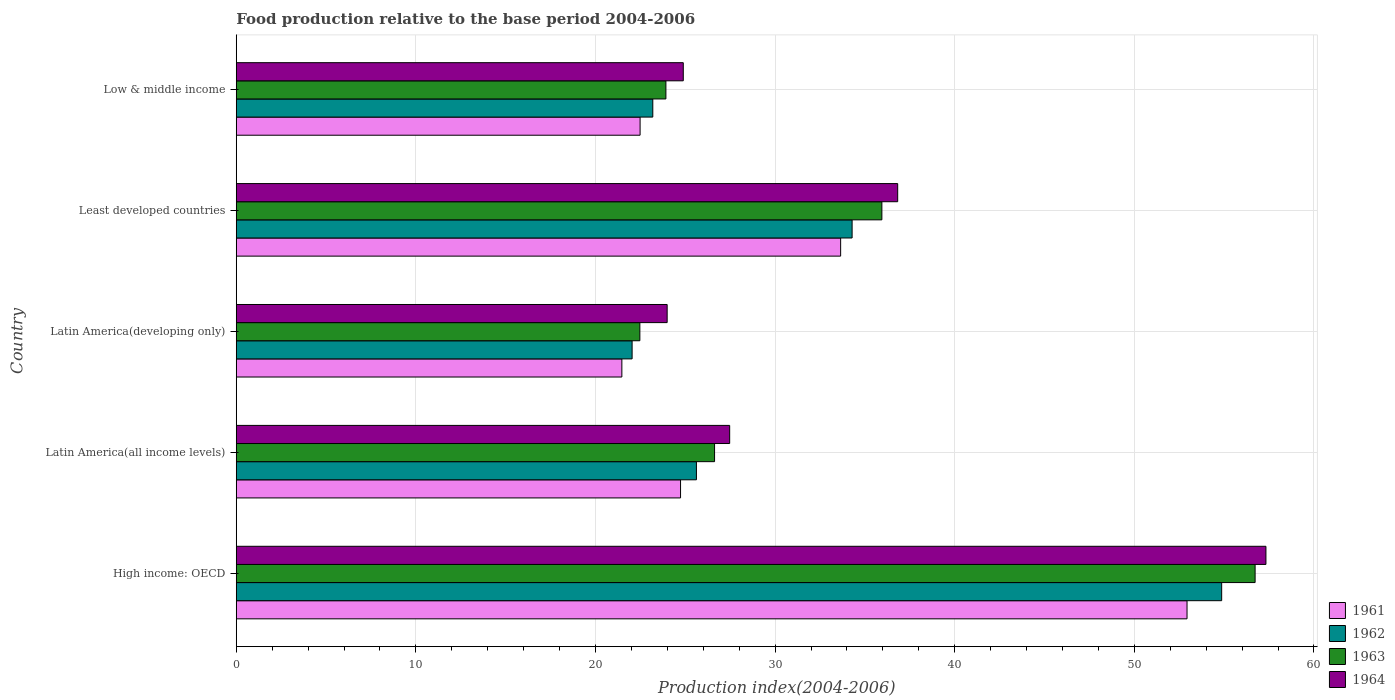Are the number of bars on each tick of the Y-axis equal?
Ensure brevity in your answer.  Yes. How many bars are there on the 2nd tick from the top?
Provide a succinct answer. 4. What is the label of the 3rd group of bars from the top?
Provide a succinct answer. Latin America(developing only). In how many cases, is the number of bars for a given country not equal to the number of legend labels?
Your response must be concise. 0. What is the food production index in 1963 in Low & middle income?
Keep it short and to the point. 23.92. Across all countries, what is the maximum food production index in 1961?
Give a very brief answer. 52.93. Across all countries, what is the minimum food production index in 1964?
Provide a succinct answer. 23.99. In which country was the food production index in 1963 maximum?
Make the answer very short. High income: OECD. In which country was the food production index in 1963 minimum?
Provide a succinct answer. Latin America(developing only). What is the total food production index in 1963 in the graph?
Your answer should be very brief. 165.69. What is the difference between the food production index in 1962 in High income: OECD and that in Low & middle income?
Ensure brevity in your answer.  31.67. What is the difference between the food production index in 1961 in Latin America(all income levels) and the food production index in 1964 in Low & middle income?
Your answer should be very brief. -0.15. What is the average food production index in 1963 per country?
Your answer should be very brief. 33.14. What is the difference between the food production index in 1961 and food production index in 1962 in Low & middle income?
Your response must be concise. -0.71. In how many countries, is the food production index in 1963 greater than 20 ?
Offer a very short reply. 5. What is the ratio of the food production index in 1964 in Latin America(developing only) to that in Least developed countries?
Your response must be concise. 0.65. Is the food production index in 1961 in Latin America(developing only) less than that in Least developed countries?
Ensure brevity in your answer.  Yes. Is the difference between the food production index in 1961 in Latin America(all income levels) and Latin America(developing only) greater than the difference between the food production index in 1962 in Latin America(all income levels) and Latin America(developing only)?
Provide a succinct answer. No. What is the difference between the highest and the second highest food production index in 1961?
Keep it short and to the point. 19.29. What is the difference between the highest and the lowest food production index in 1963?
Offer a terse response. 34.25. What does the 2nd bar from the bottom in Low & middle income represents?
Your answer should be compact. 1962. Is it the case that in every country, the sum of the food production index in 1963 and food production index in 1964 is greater than the food production index in 1961?
Provide a short and direct response. Yes. Are all the bars in the graph horizontal?
Provide a short and direct response. Yes. What is the difference between two consecutive major ticks on the X-axis?
Make the answer very short. 10. Are the values on the major ticks of X-axis written in scientific E-notation?
Your response must be concise. No. Does the graph contain grids?
Your answer should be very brief. Yes. Where does the legend appear in the graph?
Ensure brevity in your answer.  Bottom right. How are the legend labels stacked?
Give a very brief answer. Vertical. What is the title of the graph?
Your answer should be compact. Food production relative to the base period 2004-2006. Does "2010" appear as one of the legend labels in the graph?
Make the answer very short. No. What is the label or title of the X-axis?
Your answer should be very brief. Production index(2004-2006). What is the label or title of the Y-axis?
Offer a terse response. Country. What is the Production index(2004-2006) in 1961 in High income: OECD?
Your response must be concise. 52.93. What is the Production index(2004-2006) in 1962 in High income: OECD?
Provide a succinct answer. 54.86. What is the Production index(2004-2006) of 1963 in High income: OECD?
Provide a short and direct response. 56.73. What is the Production index(2004-2006) in 1964 in High income: OECD?
Your answer should be very brief. 57.33. What is the Production index(2004-2006) of 1961 in Latin America(all income levels)?
Your response must be concise. 24.74. What is the Production index(2004-2006) of 1962 in Latin America(all income levels)?
Ensure brevity in your answer.  25.62. What is the Production index(2004-2006) of 1963 in Latin America(all income levels)?
Your answer should be compact. 26.63. What is the Production index(2004-2006) of 1964 in Latin America(all income levels)?
Give a very brief answer. 27.47. What is the Production index(2004-2006) in 1961 in Latin America(developing only)?
Ensure brevity in your answer.  21.47. What is the Production index(2004-2006) in 1962 in Latin America(developing only)?
Provide a succinct answer. 22.04. What is the Production index(2004-2006) in 1963 in Latin America(developing only)?
Provide a succinct answer. 22.47. What is the Production index(2004-2006) of 1964 in Latin America(developing only)?
Your response must be concise. 23.99. What is the Production index(2004-2006) in 1961 in Least developed countries?
Provide a succinct answer. 33.65. What is the Production index(2004-2006) in 1962 in Least developed countries?
Ensure brevity in your answer.  34.29. What is the Production index(2004-2006) of 1963 in Least developed countries?
Offer a very short reply. 35.95. What is the Production index(2004-2006) of 1964 in Least developed countries?
Your response must be concise. 36.83. What is the Production index(2004-2006) in 1961 in Low & middle income?
Give a very brief answer. 22.48. What is the Production index(2004-2006) of 1962 in Low & middle income?
Provide a succinct answer. 23.19. What is the Production index(2004-2006) in 1963 in Low & middle income?
Provide a short and direct response. 23.92. What is the Production index(2004-2006) of 1964 in Low & middle income?
Provide a succinct answer. 24.89. Across all countries, what is the maximum Production index(2004-2006) of 1961?
Make the answer very short. 52.93. Across all countries, what is the maximum Production index(2004-2006) in 1962?
Your answer should be very brief. 54.86. Across all countries, what is the maximum Production index(2004-2006) in 1963?
Provide a succinct answer. 56.73. Across all countries, what is the maximum Production index(2004-2006) in 1964?
Your response must be concise. 57.33. Across all countries, what is the minimum Production index(2004-2006) of 1961?
Your response must be concise. 21.47. Across all countries, what is the minimum Production index(2004-2006) in 1962?
Ensure brevity in your answer.  22.04. Across all countries, what is the minimum Production index(2004-2006) in 1963?
Your answer should be very brief. 22.47. Across all countries, what is the minimum Production index(2004-2006) of 1964?
Keep it short and to the point. 23.99. What is the total Production index(2004-2006) in 1961 in the graph?
Give a very brief answer. 155.27. What is the total Production index(2004-2006) in 1962 in the graph?
Your answer should be very brief. 160. What is the total Production index(2004-2006) of 1963 in the graph?
Offer a very short reply. 165.69. What is the total Production index(2004-2006) of 1964 in the graph?
Offer a terse response. 170.5. What is the difference between the Production index(2004-2006) in 1961 in High income: OECD and that in Latin America(all income levels)?
Keep it short and to the point. 28.2. What is the difference between the Production index(2004-2006) in 1962 in High income: OECD and that in Latin America(all income levels)?
Make the answer very short. 29.24. What is the difference between the Production index(2004-2006) in 1963 in High income: OECD and that in Latin America(all income levels)?
Your response must be concise. 30.1. What is the difference between the Production index(2004-2006) of 1964 in High income: OECD and that in Latin America(all income levels)?
Give a very brief answer. 29.86. What is the difference between the Production index(2004-2006) in 1961 in High income: OECD and that in Latin America(developing only)?
Make the answer very short. 31.47. What is the difference between the Production index(2004-2006) of 1962 in High income: OECD and that in Latin America(developing only)?
Provide a short and direct response. 32.82. What is the difference between the Production index(2004-2006) of 1963 in High income: OECD and that in Latin America(developing only)?
Give a very brief answer. 34.25. What is the difference between the Production index(2004-2006) of 1964 in High income: OECD and that in Latin America(developing only)?
Offer a terse response. 33.34. What is the difference between the Production index(2004-2006) of 1961 in High income: OECD and that in Least developed countries?
Offer a terse response. 19.29. What is the difference between the Production index(2004-2006) of 1962 in High income: OECD and that in Least developed countries?
Keep it short and to the point. 20.57. What is the difference between the Production index(2004-2006) in 1963 in High income: OECD and that in Least developed countries?
Your response must be concise. 20.78. What is the difference between the Production index(2004-2006) of 1964 in High income: OECD and that in Least developed countries?
Give a very brief answer. 20.5. What is the difference between the Production index(2004-2006) of 1961 in High income: OECD and that in Low & middle income?
Keep it short and to the point. 30.45. What is the difference between the Production index(2004-2006) in 1962 in High income: OECD and that in Low & middle income?
Provide a succinct answer. 31.67. What is the difference between the Production index(2004-2006) of 1963 in High income: OECD and that in Low & middle income?
Offer a very short reply. 32.8. What is the difference between the Production index(2004-2006) of 1964 in High income: OECD and that in Low & middle income?
Offer a very short reply. 32.44. What is the difference between the Production index(2004-2006) of 1961 in Latin America(all income levels) and that in Latin America(developing only)?
Your response must be concise. 3.27. What is the difference between the Production index(2004-2006) in 1962 in Latin America(all income levels) and that in Latin America(developing only)?
Ensure brevity in your answer.  3.58. What is the difference between the Production index(2004-2006) of 1963 in Latin America(all income levels) and that in Latin America(developing only)?
Provide a succinct answer. 4.16. What is the difference between the Production index(2004-2006) of 1964 in Latin America(all income levels) and that in Latin America(developing only)?
Provide a short and direct response. 3.48. What is the difference between the Production index(2004-2006) in 1961 in Latin America(all income levels) and that in Least developed countries?
Keep it short and to the point. -8.91. What is the difference between the Production index(2004-2006) of 1962 in Latin America(all income levels) and that in Least developed countries?
Provide a succinct answer. -8.67. What is the difference between the Production index(2004-2006) of 1963 in Latin America(all income levels) and that in Least developed countries?
Your response must be concise. -9.32. What is the difference between the Production index(2004-2006) of 1964 in Latin America(all income levels) and that in Least developed countries?
Make the answer very short. -9.35. What is the difference between the Production index(2004-2006) in 1961 in Latin America(all income levels) and that in Low & middle income?
Provide a short and direct response. 2.25. What is the difference between the Production index(2004-2006) in 1962 in Latin America(all income levels) and that in Low & middle income?
Your answer should be compact. 2.43. What is the difference between the Production index(2004-2006) in 1963 in Latin America(all income levels) and that in Low & middle income?
Keep it short and to the point. 2.71. What is the difference between the Production index(2004-2006) in 1964 in Latin America(all income levels) and that in Low & middle income?
Your answer should be very brief. 2.58. What is the difference between the Production index(2004-2006) in 1961 in Latin America(developing only) and that in Least developed countries?
Offer a very short reply. -12.18. What is the difference between the Production index(2004-2006) in 1962 in Latin America(developing only) and that in Least developed countries?
Keep it short and to the point. -12.25. What is the difference between the Production index(2004-2006) of 1963 in Latin America(developing only) and that in Least developed countries?
Ensure brevity in your answer.  -13.47. What is the difference between the Production index(2004-2006) in 1964 in Latin America(developing only) and that in Least developed countries?
Provide a short and direct response. -12.83. What is the difference between the Production index(2004-2006) of 1961 in Latin America(developing only) and that in Low & middle income?
Offer a very short reply. -1.01. What is the difference between the Production index(2004-2006) of 1962 in Latin America(developing only) and that in Low & middle income?
Offer a very short reply. -1.15. What is the difference between the Production index(2004-2006) in 1963 in Latin America(developing only) and that in Low & middle income?
Offer a very short reply. -1.45. What is the difference between the Production index(2004-2006) in 1964 in Latin America(developing only) and that in Low & middle income?
Ensure brevity in your answer.  -0.9. What is the difference between the Production index(2004-2006) in 1961 in Least developed countries and that in Low & middle income?
Offer a very short reply. 11.17. What is the difference between the Production index(2004-2006) in 1962 in Least developed countries and that in Low & middle income?
Make the answer very short. 11.1. What is the difference between the Production index(2004-2006) in 1963 in Least developed countries and that in Low & middle income?
Make the answer very short. 12.02. What is the difference between the Production index(2004-2006) of 1964 in Least developed countries and that in Low & middle income?
Your response must be concise. 11.94. What is the difference between the Production index(2004-2006) of 1961 in High income: OECD and the Production index(2004-2006) of 1962 in Latin America(all income levels)?
Make the answer very short. 27.31. What is the difference between the Production index(2004-2006) of 1961 in High income: OECD and the Production index(2004-2006) of 1963 in Latin America(all income levels)?
Offer a very short reply. 26.3. What is the difference between the Production index(2004-2006) in 1961 in High income: OECD and the Production index(2004-2006) in 1964 in Latin America(all income levels)?
Make the answer very short. 25.46. What is the difference between the Production index(2004-2006) in 1962 in High income: OECD and the Production index(2004-2006) in 1963 in Latin America(all income levels)?
Offer a very short reply. 28.23. What is the difference between the Production index(2004-2006) in 1962 in High income: OECD and the Production index(2004-2006) in 1964 in Latin America(all income levels)?
Ensure brevity in your answer.  27.39. What is the difference between the Production index(2004-2006) in 1963 in High income: OECD and the Production index(2004-2006) in 1964 in Latin America(all income levels)?
Give a very brief answer. 29.25. What is the difference between the Production index(2004-2006) of 1961 in High income: OECD and the Production index(2004-2006) of 1962 in Latin America(developing only)?
Provide a short and direct response. 30.89. What is the difference between the Production index(2004-2006) in 1961 in High income: OECD and the Production index(2004-2006) in 1963 in Latin America(developing only)?
Provide a succinct answer. 30.46. What is the difference between the Production index(2004-2006) in 1961 in High income: OECD and the Production index(2004-2006) in 1964 in Latin America(developing only)?
Your answer should be compact. 28.94. What is the difference between the Production index(2004-2006) of 1962 in High income: OECD and the Production index(2004-2006) of 1963 in Latin America(developing only)?
Your answer should be compact. 32.39. What is the difference between the Production index(2004-2006) in 1962 in High income: OECD and the Production index(2004-2006) in 1964 in Latin America(developing only)?
Provide a succinct answer. 30.87. What is the difference between the Production index(2004-2006) of 1963 in High income: OECD and the Production index(2004-2006) of 1964 in Latin America(developing only)?
Your answer should be compact. 32.73. What is the difference between the Production index(2004-2006) in 1961 in High income: OECD and the Production index(2004-2006) in 1962 in Least developed countries?
Your response must be concise. 18.65. What is the difference between the Production index(2004-2006) of 1961 in High income: OECD and the Production index(2004-2006) of 1963 in Least developed countries?
Ensure brevity in your answer.  16.99. What is the difference between the Production index(2004-2006) in 1961 in High income: OECD and the Production index(2004-2006) in 1964 in Least developed countries?
Provide a short and direct response. 16.11. What is the difference between the Production index(2004-2006) of 1962 in High income: OECD and the Production index(2004-2006) of 1963 in Least developed countries?
Offer a terse response. 18.92. What is the difference between the Production index(2004-2006) of 1962 in High income: OECD and the Production index(2004-2006) of 1964 in Least developed countries?
Your answer should be compact. 18.04. What is the difference between the Production index(2004-2006) in 1961 in High income: OECD and the Production index(2004-2006) in 1962 in Low & middle income?
Offer a very short reply. 29.74. What is the difference between the Production index(2004-2006) of 1961 in High income: OECD and the Production index(2004-2006) of 1963 in Low & middle income?
Ensure brevity in your answer.  29.01. What is the difference between the Production index(2004-2006) of 1961 in High income: OECD and the Production index(2004-2006) of 1964 in Low & middle income?
Your answer should be compact. 28.05. What is the difference between the Production index(2004-2006) in 1962 in High income: OECD and the Production index(2004-2006) in 1963 in Low & middle income?
Offer a very short reply. 30.94. What is the difference between the Production index(2004-2006) of 1962 in High income: OECD and the Production index(2004-2006) of 1964 in Low & middle income?
Your response must be concise. 29.97. What is the difference between the Production index(2004-2006) in 1963 in High income: OECD and the Production index(2004-2006) in 1964 in Low & middle income?
Your answer should be very brief. 31.84. What is the difference between the Production index(2004-2006) of 1961 in Latin America(all income levels) and the Production index(2004-2006) of 1962 in Latin America(developing only)?
Offer a very short reply. 2.7. What is the difference between the Production index(2004-2006) of 1961 in Latin America(all income levels) and the Production index(2004-2006) of 1963 in Latin America(developing only)?
Your response must be concise. 2.27. What is the difference between the Production index(2004-2006) in 1961 in Latin America(all income levels) and the Production index(2004-2006) in 1964 in Latin America(developing only)?
Offer a very short reply. 0.75. What is the difference between the Production index(2004-2006) of 1962 in Latin America(all income levels) and the Production index(2004-2006) of 1963 in Latin America(developing only)?
Ensure brevity in your answer.  3.15. What is the difference between the Production index(2004-2006) in 1962 in Latin America(all income levels) and the Production index(2004-2006) in 1964 in Latin America(developing only)?
Ensure brevity in your answer.  1.63. What is the difference between the Production index(2004-2006) in 1963 in Latin America(all income levels) and the Production index(2004-2006) in 1964 in Latin America(developing only)?
Offer a terse response. 2.64. What is the difference between the Production index(2004-2006) of 1961 in Latin America(all income levels) and the Production index(2004-2006) of 1962 in Least developed countries?
Offer a terse response. -9.55. What is the difference between the Production index(2004-2006) in 1961 in Latin America(all income levels) and the Production index(2004-2006) in 1963 in Least developed countries?
Your answer should be very brief. -11.21. What is the difference between the Production index(2004-2006) of 1961 in Latin America(all income levels) and the Production index(2004-2006) of 1964 in Least developed countries?
Your answer should be compact. -12.09. What is the difference between the Production index(2004-2006) in 1962 in Latin America(all income levels) and the Production index(2004-2006) in 1963 in Least developed countries?
Give a very brief answer. -10.33. What is the difference between the Production index(2004-2006) in 1962 in Latin America(all income levels) and the Production index(2004-2006) in 1964 in Least developed countries?
Make the answer very short. -11.21. What is the difference between the Production index(2004-2006) in 1963 in Latin America(all income levels) and the Production index(2004-2006) in 1964 in Least developed countries?
Ensure brevity in your answer.  -10.2. What is the difference between the Production index(2004-2006) in 1961 in Latin America(all income levels) and the Production index(2004-2006) in 1962 in Low & middle income?
Offer a terse response. 1.54. What is the difference between the Production index(2004-2006) of 1961 in Latin America(all income levels) and the Production index(2004-2006) of 1963 in Low & middle income?
Give a very brief answer. 0.82. What is the difference between the Production index(2004-2006) in 1961 in Latin America(all income levels) and the Production index(2004-2006) in 1964 in Low & middle income?
Provide a succinct answer. -0.15. What is the difference between the Production index(2004-2006) in 1962 in Latin America(all income levels) and the Production index(2004-2006) in 1963 in Low & middle income?
Your answer should be very brief. 1.7. What is the difference between the Production index(2004-2006) of 1962 in Latin America(all income levels) and the Production index(2004-2006) of 1964 in Low & middle income?
Provide a short and direct response. 0.73. What is the difference between the Production index(2004-2006) in 1963 in Latin America(all income levels) and the Production index(2004-2006) in 1964 in Low & middle income?
Your answer should be compact. 1.74. What is the difference between the Production index(2004-2006) in 1961 in Latin America(developing only) and the Production index(2004-2006) in 1962 in Least developed countries?
Your answer should be compact. -12.82. What is the difference between the Production index(2004-2006) of 1961 in Latin America(developing only) and the Production index(2004-2006) of 1963 in Least developed countries?
Provide a succinct answer. -14.48. What is the difference between the Production index(2004-2006) in 1961 in Latin America(developing only) and the Production index(2004-2006) in 1964 in Least developed countries?
Ensure brevity in your answer.  -15.36. What is the difference between the Production index(2004-2006) of 1962 in Latin America(developing only) and the Production index(2004-2006) of 1963 in Least developed countries?
Your response must be concise. -13.91. What is the difference between the Production index(2004-2006) in 1962 in Latin America(developing only) and the Production index(2004-2006) in 1964 in Least developed countries?
Offer a terse response. -14.79. What is the difference between the Production index(2004-2006) in 1963 in Latin America(developing only) and the Production index(2004-2006) in 1964 in Least developed countries?
Your answer should be very brief. -14.35. What is the difference between the Production index(2004-2006) of 1961 in Latin America(developing only) and the Production index(2004-2006) of 1962 in Low & middle income?
Offer a very short reply. -1.72. What is the difference between the Production index(2004-2006) in 1961 in Latin America(developing only) and the Production index(2004-2006) in 1963 in Low & middle income?
Keep it short and to the point. -2.45. What is the difference between the Production index(2004-2006) of 1961 in Latin America(developing only) and the Production index(2004-2006) of 1964 in Low & middle income?
Keep it short and to the point. -3.42. What is the difference between the Production index(2004-2006) in 1962 in Latin America(developing only) and the Production index(2004-2006) in 1963 in Low & middle income?
Provide a succinct answer. -1.88. What is the difference between the Production index(2004-2006) of 1962 in Latin America(developing only) and the Production index(2004-2006) of 1964 in Low & middle income?
Your response must be concise. -2.85. What is the difference between the Production index(2004-2006) in 1963 in Latin America(developing only) and the Production index(2004-2006) in 1964 in Low & middle income?
Your answer should be very brief. -2.42. What is the difference between the Production index(2004-2006) in 1961 in Least developed countries and the Production index(2004-2006) in 1962 in Low & middle income?
Give a very brief answer. 10.46. What is the difference between the Production index(2004-2006) of 1961 in Least developed countries and the Production index(2004-2006) of 1963 in Low & middle income?
Make the answer very short. 9.73. What is the difference between the Production index(2004-2006) of 1961 in Least developed countries and the Production index(2004-2006) of 1964 in Low & middle income?
Provide a short and direct response. 8.76. What is the difference between the Production index(2004-2006) of 1962 in Least developed countries and the Production index(2004-2006) of 1963 in Low & middle income?
Ensure brevity in your answer.  10.37. What is the difference between the Production index(2004-2006) of 1962 in Least developed countries and the Production index(2004-2006) of 1964 in Low & middle income?
Provide a succinct answer. 9.4. What is the difference between the Production index(2004-2006) in 1963 in Least developed countries and the Production index(2004-2006) in 1964 in Low & middle income?
Make the answer very short. 11.06. What is the average Production index(2004-2006) in 1961 per country?
Make the answer very short. 31.05. What is the average Production index(2004-2006) in 1962 per country?
Offer a very short reply. 32. What is the average Production index(2004-2006) of 1963 per country?
Your answer should be very brief. 33.14. What is the average Production index(2004-2006) in 1964 per country?
Offer a terse response. 34.1. What is the difference between the Production index(2004-2006) in 1961 and Production index(2004-2006) in 1962 in High income: OECD?
Make the answer very short. -1.93. What is the difference between the Production index(2004-2006) in 1961 and Production index(2004-2006) in 1963 in High income: OECD?
Your answer should be very brief. -3.79. What is the difference between the Production index(2004-2006) in 1961 and Production index(2004-2006) in 1964 in High income: OECD?
Keep it short and to the point. -4.39. What is the difference between the Production index(2004-2006) in 1962 and Production index(2004-2006) in 1963 in High income: OECD?
Your answer should be compact. -1.86. What is the difference between the Production index(2004-2006) in 1962 and Production index(2004-2006) in 1964 in High income: OECD?
Ensure brevity in your answer.  -2.47. What is the difference between the Production index(2004-2006) of 1963 and Production index(2004-2006) of 1964 in High income: OECD?
Give a very brief answer. -0.6. What is the difference between the Production index(2004-2006) of 1961 and Production index(2004-2006) of 1962 in Latin America(all income levels)?
Provide a short and direct response. -0.88. What is the difference between the Production index(2004-2006) in 1961 and Production index(2004-2006) in 1963 in Latin America(all income levels)?
Offer a very short reply. -1.89. What is the difference between the Production index(2004-2006) of 1961 and Production index(2004-2006) of 1964 in Latin America(all income levels)?
Provide a succinct answer. -2.74. What is the difference between the Production index(2004-2006) in 1962 and Production index(2004-2006) in 1963 in Latin America(all income levels)?
Provide a short and direct response. -1.01. What is the difference between the Production index(2004-2006) in 1962 and Production index(2004-2006) in 1964 in Latin America(all income levels)?
Provide a succinct answer. -1.85. What is the difference between the Production index(2004-2006) of 1963 and Production index(2004-2006) of 1964 in Latin America(all income levels)?
Give a very brief answer. -0.84. What is the difference between the Production index(2004-2006) of 1961 and Production index(2004-2006) of 1962 in Latin America(developing only)?
Offer a very short reply. -0.57. What is the difference between the Production index(2004-2006) in 1961 and Production index(2004-2006) in 1963 in Latin America(developing only)?
Make the answer very short. -1. What is the difference between the Production index(2004-2006) of 1961 and Production index(2004-2006) of 1964 in Latin America(developing only)?
Ensure brevity in your answer.  -2.52. What is the difference between the Production index(2004-2006) of 1962 and Production index(2004-2006) of 1963 in Latin America(developing only)?
Your response must be concise. -0.43. What is the difference between the Production index(2004-2006) in 1962 and Production index(2004-2006) in 1964 in Latin America(developing only)?
Your answer should be compact. -1.95. What is the difference between the Production index(2004-2006) of 1963 and Production index(2004-2006) of 1964 in Latin America(developing only)?
Make the answer very short. -1.52. What is the difference between the Production index(2004-2006) of 1961 and Production index(2004-2006) of 1962 in Least developed countries?
Provide a succinct answer. -0.64. What is the difference between the Production index(2004-2006) in 1961 and Production index(2004-2006) in 1963 in Least developed countries?
Provide a short and direct response. -2.3. What is the difference between the Production index(2004-2006) of 1961 and Production index(2004-2006) of 1964 in Least developed countries?
Ensure brevity in your answer.  -3.18. What is the difference between the Production index(2004-2006) in 1962 and Production index(2004-2006) in 1963 in Least developed countries?
Keep it short and to the point. -1.66. What is the difference between the Production index(2004-2006) in 1962 and Production index(2004-2006) in 1964 in Least developed countries?
Your response must be concise. -2.54. What is the difference between the Production index(2004-2006) in 1963 and Production index(2004-2006) in 1964 in Least developed countries?
Offer a terse response. -0.88. What is the difference between the Production index(2004-2006) in 1961 and Production index(2004-2006) in 1962 in Low & middle income?
Make the answer very short. -0.71. What is the difference between the Production index(2004-2006) in 1961 and Production index(2004-2006) in 1963 in Low & middle income?
Your answer should be compact. -1.44. What is the difference between the Production index(2004-2006) in 1961 and Production index(2004-2006) in 1964 in Low & middle income?
Ensure brevity in your answer.  -2.4. What is the difference between the Production index(2004-2006) in 1962 and Production index(2004-2006) in 1963 in Low & middle income?
Your answer should be very brief. -0.73. What is the difference between the Production index(2004-2006) of 1962 and Production index(2004-2006) of 1964 in Low & middle income?
Give a very brief answer. -1.7. What is the difference between the Production index(2004-2006) in 1963 and Production index(2004-2006) in 1964 in Low & middle income?
Your answer should be very brief. -0.97. What is the ratio of the Production index(2004-2006) in 1961 in High income: OECD to that in Latin America(all income levels)?
Ensure brevity in your answer.  2.14. What is the ratio of the Production index(2004-2006) in 1962 in High income: OECD to that in Latin America(all income levels)?
Provide a succinct answer. 2.14. What is the ratio of the Production index(2004-2006) of 1963 in High income: OECD to that in Latin America(all income levels)?
Make the answer very short. 2.13. What is the ratio of the Production index(2004-2006) in 1964 in High income: OECD to that in Latin America(all income levels)?
Keep it short and to the point. 2.09. What is the ratio of the Production index(2004-2006) in 1961 in High income: OECD to that in Latin America(developing only)?
Provide a short and direct response. 2.47. What is the ratio of the Production index(2004-2006) in 1962 in High income: OECD to that in Latin America(developing only)?
Make the answer very short. 2.49. What is the ratio of the Production index(2004-2006) of 1963 in High income: OECD to that in Latin America(developing only)?
Provide a succinct answer. 2.52. What is the ratio of the Production index(2004-2006) of 1964 in High income: OECD to that in Latin America(developing only)?
Offer a terse response. 2.39. What is the ratio of the Production index(2004-2006) in 1961 in High income: OECD to that in Least developed countries?
Provide a succinct answer. 1.57. What is the ratio of the Production index(2004-2006) in 1962 in High income: OECD to that in Least developed countries?
Keep it short and to the point. 1.6. What is the ratio of the Production index(2004-2006) of 1963 in High income: OECD to that in Least developed countries?
Your answer should be compact. 1.58. What is the ratio of the Production index(2004-2006) in 1964 in High income: OECD to that in Least developed countries?
Make the answer very short. 1.56. What is the ratio of the Production index(2004-2006) in 1961 in High income: OECD to that in Low & middle income?
Make the answer very short. 2.35. What is the ratio of the Production index(2004-2006) in 1962 in High income: OECD to that in Low & middle income?
Your response must be concise. 2.37. What is the ratio of the Production index(2004-2006) of 1963 in High income: OECD to that in Low & middle income?
Provide a short and direct response. 2.37. What is the ratio of the Production index(2004-2006) of 1964 in High income: OECD to that in Low & middle income?
Ensure brevity in your answer.  2.3. What is the ratio of the Production index(2004-2006) of 1961 in Latin America(all income levels) to that in Latin America(developing only)?
Your response must be concise. 1.15. What is the ratio of the Production index(2004-2006) in 1962 in Latin America(all income levels) to that in Latin America(developing only)?
Provide a short and direct response. 1.16. What is the ratio of the Production index(2004-2006) of 1963 in Latin America(all income levels) to that in Latin America(developing only)?
Your answer should be very brief. 1.19. What is the ratio of the Production index(2004-2006) of 1964 in Latin America(all income levels) to that in Latin America(developing only)?
Provide a short and direct response. 1.15. What is the ratio of the Production index(2004-2006) in 1961 in Latin America(all income levels) to that in Least developed countries?
Give a very brief answer. 0.74. What is the ratio of the Production index(2004-2006) of 1962 in Latin America(all income levels) to that in Least developed countries?
Ensure brevity in your answer.  0.75. What is the ratio of the Production index(2004-2006) in 1963 in Latin America(all income levels) to that in Least developed countries?
Your response must be concise. 0.74. What is the ratio of the Production index(2004-2006) of 1964 in Latin America(all income levels) to that in Least developed countries?
Your response must be concise. 0.75. What is the ratio of the Production index(2004-2006) in 1961 in Latin America(all income levels) to that in Low & middle income?
Offer a terse response. 1.1. What is the ratio of the Production index(2004-2006) of 1962 in Latin America(all income levels) to that in Low & middle income?
Ensure brevity in your answer.  1.1. What is the ratio of the Production index(2004-2006) of 1963 in Latin America(all income levels) to that in Low & middle income?
Make the answer very short. 1.11. What is the ratio of the Production index(2004-2006) in 1964 in Latin America(all income levels) to that in Low & middle income?
Your answer should be very brief. 1.1. What is the ratio of the Production index(2004-2006) in 1961 in Latin America(developing only) to that in Least developed countries?
Make the answer very short. 0.64. What is the ratio of the Production index(2004-2006) of 1962 in Latin America(developing only) to that in Least developed countries?
Keep it short and to the point. 0.64. What is the ratio of the Production index(2004-2006) of 1963 in Latin America(developing only) to that in Least developed countries?
Keep it short and to the point. 0.63. What is the ratio of the Production index(2004-2006) of 1964 in Latin America(developing only) to that in Least developed countries?
Your answer should be compact. 0.65. What is the ratio of the Production index(2004-2006) of 1961 in Latin America(developing only) to that in Low & middle income?
Your answer should be compact. 0.95. What is the ratio of the Production index(2004-2006) in 1962 in Latin America(developing only) to that in Low & middle income?
Provide a succinct answer. 0.95. What is the ratio of the Production index(2004-2006) of 1963 in Latin America(developing only) to that in Low & middle income?
Give a very brief answer. 0.94. What is the ratio of the Production index(2004-2006) of 1964 in Latin America(developing only) to that in Low & middle income?
Provide a short and direct response. 0.96. What is the ratio of the Production index(2004-2006) of 1961 in Least developed countries to that in Low & middle income?
Provide a succinct answer. 1.5. What is the ratio of the Production index(2004-2006) in 1962 in Least developed countries to that in Low & middle income?
Provide a short and direct response. 1.48. What is the ratio of the Production index(2004-2006) of 1963 in Least developed countries to that in Low & middle income?
Ensure brevity in your answer.  1.5. What is the ratio of the Production index(2004-2006) in 1964 in Least developed countries to that in Low & middle income?
Your response must be concise. 1.48. What is the difference between the highest and the second highest Production index(2004-2006) in 1961?
Provide a short and direct response. 19.29. What is the difference between the highest and the second highest Production index(2004-2006) of 1962?
Provide a succinct answer. 20.57. What is the difference between the highest and the second highest Production index(2004-2006) of 1963?
Ensure brevity in your answer.  20.78. What is the difference between the highest and the second highest Production index(2004-2006) of 1964?
Make the answer very short. 20.5. What is the difference between the highest and the lowest Production index(2004-2006) in 1961?
Offer a very short reply. 31.47. What is the difference between the highest and the lowest Production index(2004-2006) in 1962?
Your answer should be compact. 32.82. What is the difference between the highest and the lowest Production index(2004-2006) of 1963?
Provide a short and direct response. 34.25. What is the difference between the highest and the lowest Production index(2004-2006) of 1964?
Ensure brevity in your answer.  33.34. 